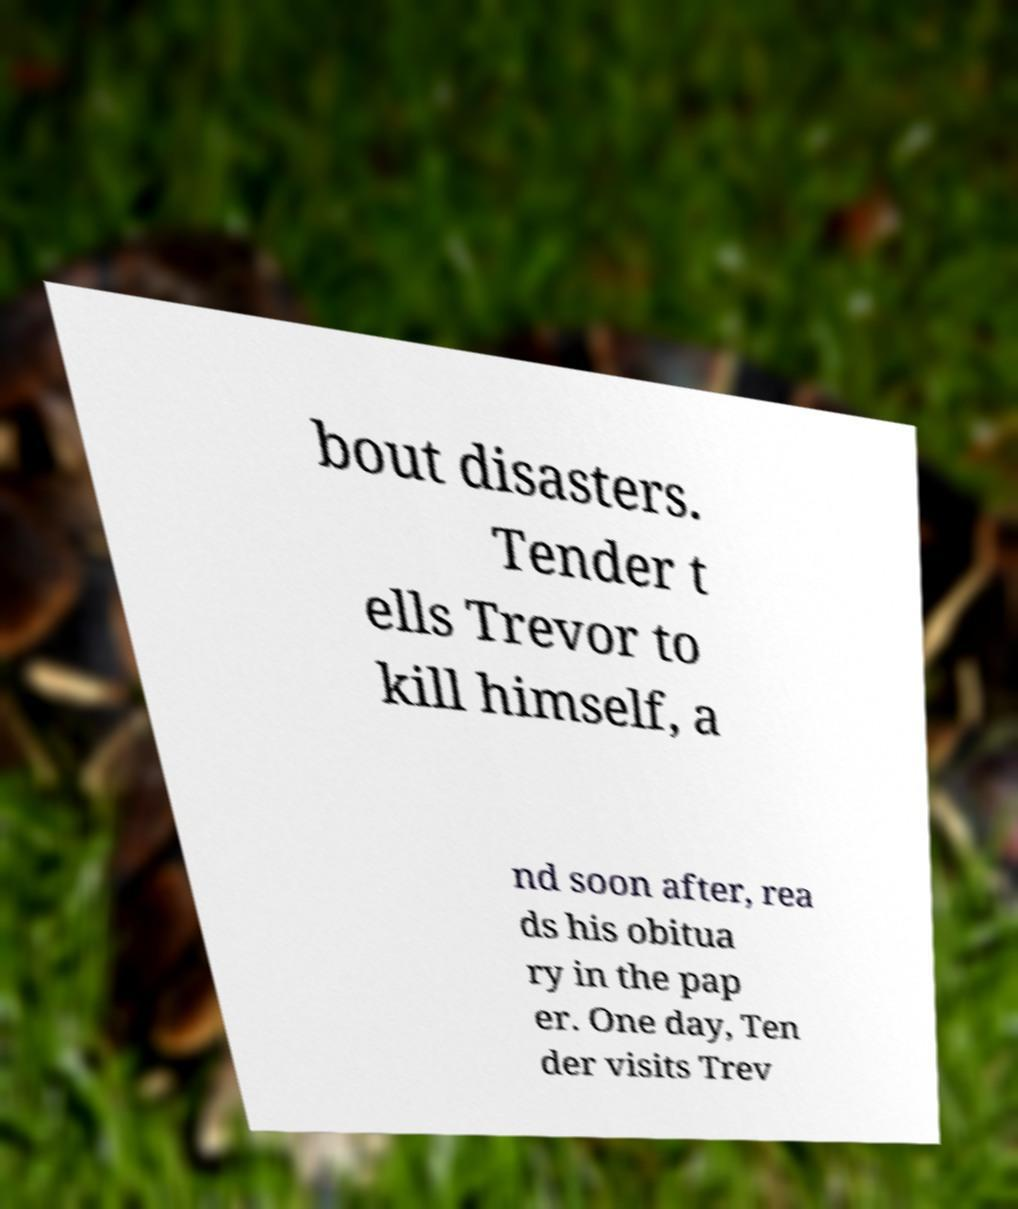Can you read and provide the text displayed in the image?This photo seems to have some interesting text. Can you extract and type it out for me? bout disasters. Tender t ells Trevor to kill himself, a nd soon after, rea ds his obitua ry in the pap er. One day, Ten der visits Trev 